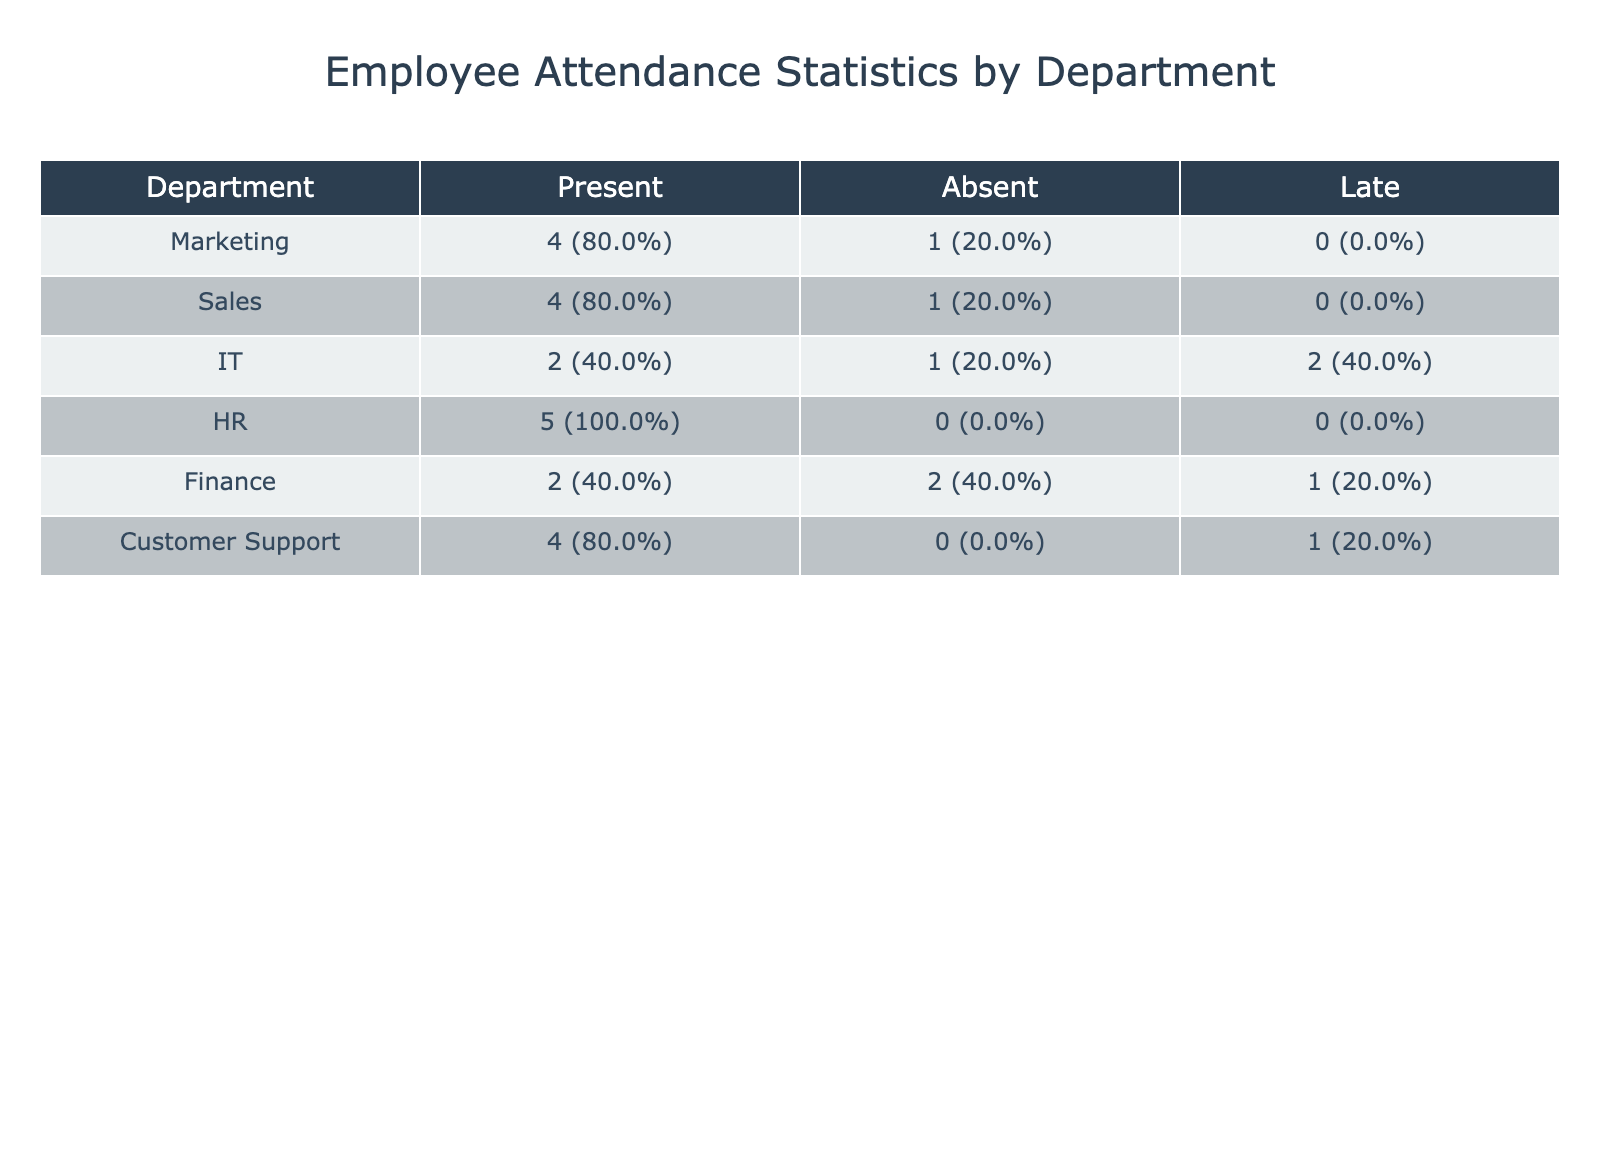What is the total attendance for the Marketing department? The Marketing department has John Smith who was Present on January 2, January 3, March 10, and April 4 (4 total). There are no absent days listed for this department in the data provided.
Answer: 4 How many employees in the Finance department were Absent? Looking at the Finance records, Emily Clark was Absent on January 3 and April 4. Therefore, there are 2 instances of absence in the Finance department.
Answer: 2 Which department had the highest percentage of Present status? By evaluating the Present counts for each department: Marketing (4 out of 4), Sales (3 out of 4), IT (2 out of 4), HR (4 out of 4), Finance (2 out of 4), and Customer Support (4 out of 4). Marketing, HR, and Customer Support all have 100% Present rates.
Answer: Marketing, HR, and Customer Support Did any employee in the IT department have more Absents than Presents? The IT department had Mike Johnson who was Present on January 2, February 1, and April 4. He was Absent on March 10. This results in 3 Presents and 1 Absent, meaning the condition is False (3 > 1).
Answer: No What is the difference in the Late attendance counts between the Sales and Customer Support departments? The Sales department has 0 Late entries whereas Customer Support has 1 (Daniel Lee on February 1). The difference is 0 - 1 = -1, indicating Customer Support had 1 more Late attendance than Sales.
Answer: -1 How many employees from HR were Present more than they were Late? Alice Davis from HR was Present for all recorded instances (January 2, January 3, February 1, April 4) and had 0 Late entries during the period. Therefore, the number of Present days (4) is greater than Late days (0).
Answer: 1 If we consider the overall attendance, what percentage of days were employees Absent across all departments for the first half of 2023? There are 24 total attendance records (4 months x 6 entries). Employees were Absent 5 times (Jane Doe on January 2; Emily Clark on January 3; Mike Johnson on March 10; Emily Clark on April 4). The Absent percentage is (5/24 x 100) = approximately 20.8%.
Answer: 20.8% Which department had the least number of Late attendances? By evaluating the Late counts: Marketing (0), Sales (0), IT (2), HR (0), Finance (0), and Customer Support (1). Departments with the least Late attendance, having 0 Late attendances, are Marketing, Sales, HR, and Finance.
Answer: Marketing, Sales, HR, and Finance Did any employee from the Customer Support department have all their records as Present? Daniel Lee from Customer Support had Present on January 2, January 3, and April 4. There Was one instance of being Late on February 1. Therefore, not all records were Present.
Answer: No 